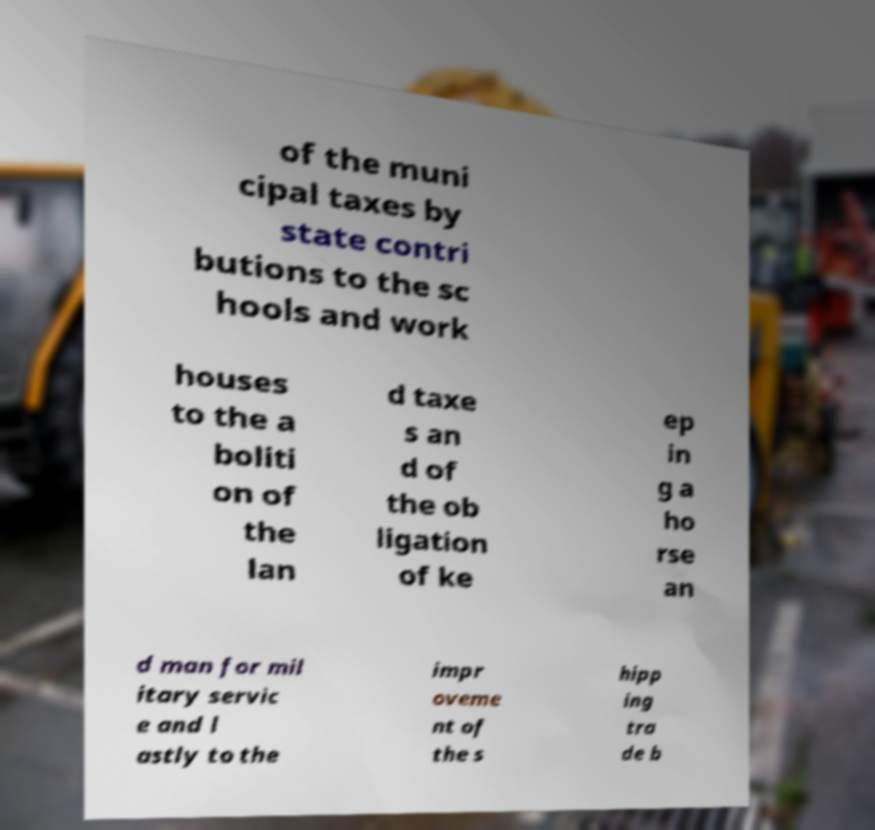What messages or text are displayed in this image? I need them in a readable, typed format. of the muni cipal taxes by state contri butions to the sc hools and work houses to the a boliti on of the lan d taxe s an d of the ob ligation of ke ep in g a ho rse an d man for mil itary servic e and l astly to the impr oveme nt of the s hipp ing tra de b 